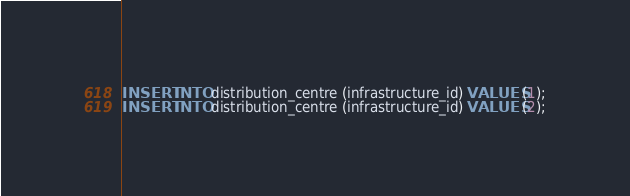<code> <loc_0><loc_0><loc_500><loc_500><_SQL_>INSERT INTO distribution_centre (infrastructure_id) VALUES (1);
INSERT INTO distribution_centre (infrastructure_id) VALUES (2);</code> 